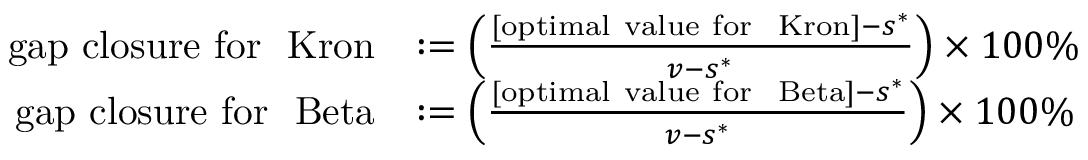Convert formula to latex. <formula><loc_0><loc_0><loc_500><loc_500>\begin{array} { r l } { g a p c l o s u r e f o r \mathrm { K r o n } } & { \colon = \left ( \frac { [ o p t i m a l v a l u e f o r \mathrm { K r o n } ] - s ^ { * } } { v - s ^ { * } } \right ) \times 1 0 0 \% } \\ { g a p c l o s u r e f o r \mathrm { B e t a } } & { \colon = \left ( \frac { [ o p t i m a l v a l u e f o r \mathrm { B e t a } ] - s ^ { * } } { v - s ^ { * } } \right ) \times 1 0 0 \% } \end{array}</formula> 